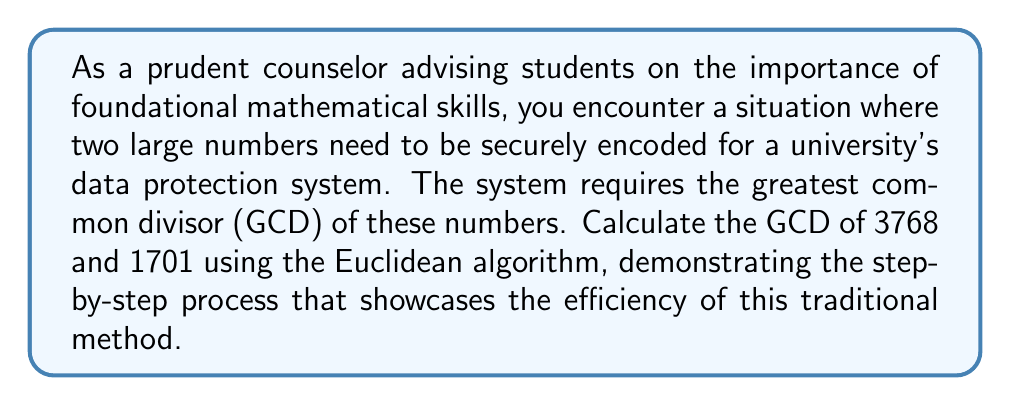Solve this math problem. Let's apply the Euclidean algorithm to find the GCD of 3768 and 1701:

1) First, set up the initial equation:
   $3768 = 2 \times 1701 + 366$

2) Now, we use the remainder (366) and divide the previous divisor (1701) by it:
   $1701 = 4 \times 366 + 237$

3) Continue this process:
   $366 = 1 \times 237 + 129$

4) $237 = 1 \times 129 + 108$

5) $129 = 1 \times 108 + 21$

6) $108 = 5 \times 21 + 3$

7) $21 = 7 \times 3 + 0$

The process stops when we get a remainder of 0. The last non-zero remainder is the GCD.

Therefore, the GCD of 3768 and 1701 is 3.

To verify:
$3768 = 3 \times 1256$
$1701 = 3 \times 567$

This method efficiently finds the GCD without factoring the large numbers, demonstrating the power of traditional algorithms in modern applications.
Answer: $\text{GCD}(3768, 1701) = 3$ 